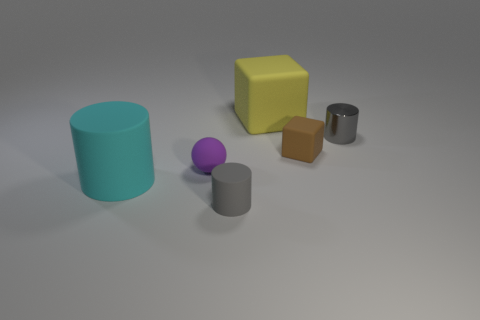How do the textures of the objects compare? The objects exhibit different textures. The metal cylinder appears smooth and reflective, whereas the other objects have a matte finish. 